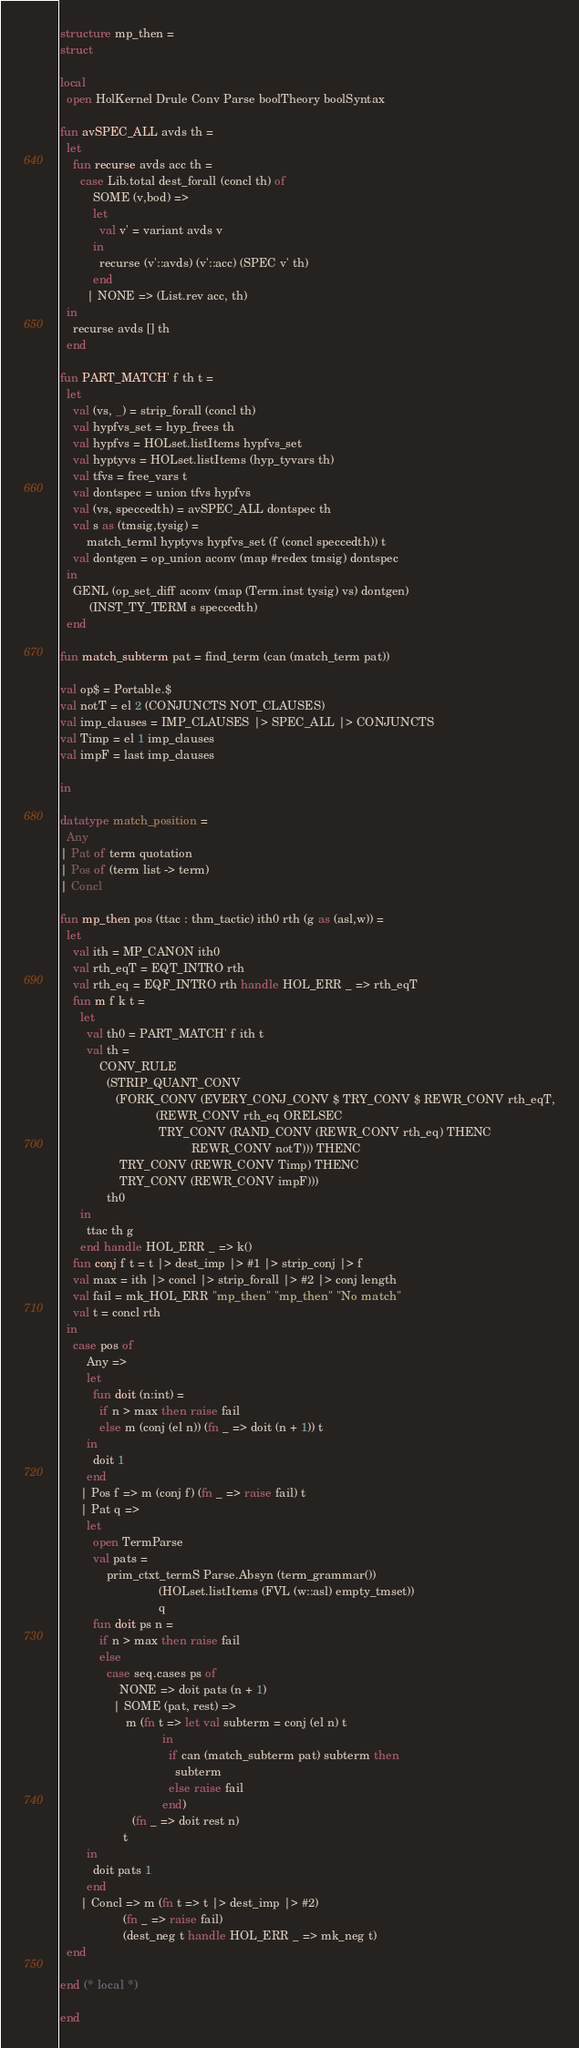<code> <loc_0><loc_0><loc_500><loc_500><_SML_>structure mp_then =
struct

local
  open HolKernel Drule Conv Parse boolTheory boolSyntax

fun avSPEC_ALL avds th =
  let
    fun recurse avds acc th =
      case Lib.total dest_forall (concl th) of
          SOME (v,bod) =>
          let
            val v' = variant avds v
          in
            recurse (v'::avds) (v'::acc) (SPEC v' th)
          end
        | NONE => (List.rev acc, th)
  in
    recurse avds [] th
  end

fun PART_MATCH' f th t =
  let
    val (vs, _) = strip_forall (concl th)
    val hypfvs_set = hyp_frees th
    val hypfvs = HOLset.listItems hypfvs_set
    val hyptyvs = HOLset.listItems (hyp_tyvars th)
    val tfvs = free_vars t
    val dontspec = union tfvs hypfvs
    val (vs, speccedth) = avSPEC_ALL dontspec th
    val s as (tmsig,tysig) =
        match_terml hyptyvs hypfvs_set (f (concl speccedth)) t
    val dontgen = op_union aconv (map #redex tmsig) dontspec
  in
    GENL (op_set_diff aconv (map (Term.inst tysig) vs) dontgen)
         (INST_TY_TERM s speccedth)
  end

fun match_subterm pat = find_term (can (match_term pat))

val op$ = Portable.$
val notT = el 2 (CONJUNCTS NOT_CLAUSES)
val imp_clauses = IMP_CLAUSES |> SPEC_ALL |> CONJUNCTS
val Timp = el 1 imp_clauses
val impF = last imp_clauses

in

datatype match_position =
  Any
| Pat of term quotation
| Pos of (term list -> term)
| Concl

fun mp_then pos (ttac : thm_tactic) ith0 rth (g as (asl,w)) =
  let
    val ith = MP_CANON ith0
    val rth_eqT = EQT_INTRO rth
    val rth_eq = EQF_INTRO rth handle HOL_ERR _ => rth_eqT
    fun m f k t =
      let
        val th0 = PART_MATCH' f ith t
        val th =
            CONV_RULE
              (STRIP_QUANT_CONV
                 (FORK_CONV (EVERY_CONJ_CONV $ TRY_CONV $ REWR_CONV rth_eqT,
                             (REWR_CONV rth_eq ORELSEC
                              TRY_CONV (RAND_CONV (REWR_CONV rth_eq) THENC
                                        REWR_CONV notT))) THENC
                  TRY_CONV (REWR_CONV Timp) THENC
                  TRY_CONV (REWR_CONV impF)))
              th0
      in
        ttac th g
      end handle HOL_ERR _ => k()
    fun conj f t = t |> dest_imp |> #1 |> strip_conj |> f
    val max = ith |> concl |> strip_forall |> #2 |> conj length
    val fail = mk_HOL_ERR "mp_then" "mp_then" "No match"
    val t = concl rth
  in
    case pos of
        Any =>
        let
          fun doit (n:int) =
            if n > max then raise fail
            else m (conj (el n)) (fn _ => doit (n + 1)) t
        in
          doit 1
        end
      | Pos f => m (conj f) (fn _ => raise fail) t
      | Pat q =>
        let
          open TermParse
          val pats =
              prim_ctxt_termS Parse.Absyn (term_grammar())
                              (HOLset.listItems (FVL (w::asl) empty_tmset))
                              q
          fun doit ps n =
            if n > max then raise fail
            else
              case seq.cases ps of
                  NONE => doit pats (n + 1)
                | SOME (pat, rest) =>
                    m (fn t => let val subterm = conj (el n) t
                               in
                                 if can (match_subterm pat) subterm then
                                   subterm
                                 else raise fail
                               end)
                      (fn _ => doit rest n)
                   t
        in
          doit pats 1
        end
      | Concl => m (fn t => t |> dest_imp |> #2)
                   (fn _ => raise fail)
                   (dest_neg t handle HOL_ERR _ => mk_neg t)
  end

end (* local *)

end
</code> 